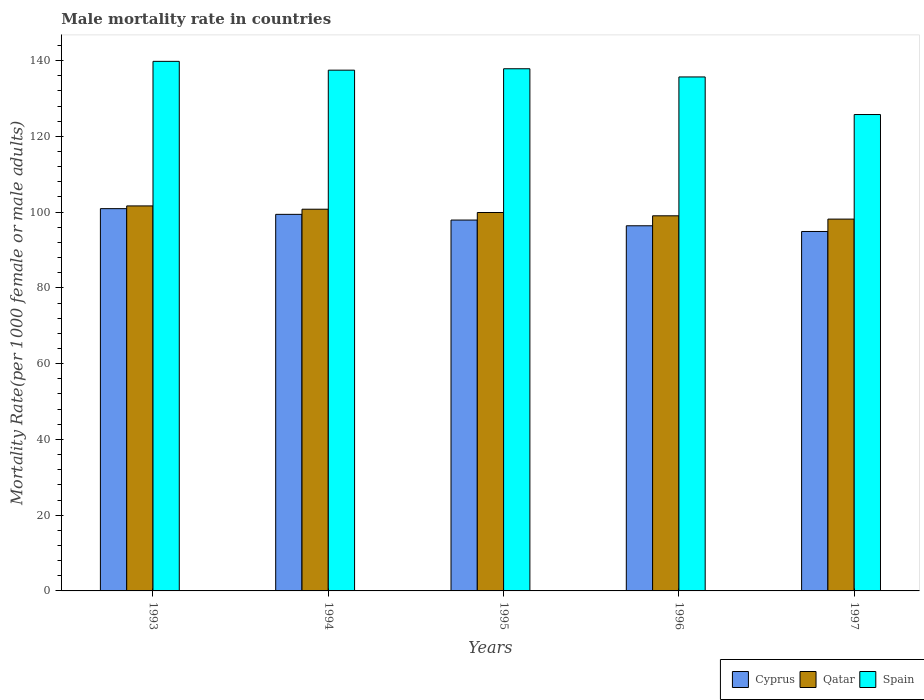How many groups of bars are there?
Provide a short and direct response. 5. Are the number of bars per tick equal to the number of legend labels?
Offer a terse response. Yes. How many bars are there on the 4th tick from the left?
Give a very brief answer. 3. How many bars are there on the 5th tick from the right?
Your answer should be very brief. 3. In how many cases, is the number of bars for a given year not equal to the number of legend labels?
Keep it short and to the point. 0. What is the male mortality rate in Cyprus in 1997?
Keep it short and to the point. 94.89. Across all years, what is the maximum male mortality rate in Spain?
Give a very brief answer. 139.81. Across all years, what is the minimum male mortality rate in Qatar?
Provide a succinct answer. 98.16. In which year was the male mortality rate in Qatar maximum?
Provide a succinct answer. 1993. What is the total male mortality rate in Qatar in the graph?
Provide a succinct answer. 499.51. What is the difference between the male mortality rate in Spain in 1995 and that in 1997?
Provide a succinct answer. 12.09. What is the difference between the male mortality rate in Cyprus in 1993 and the male mortality rate in Spain in 1994?
Offer a terse response. -36.56. What is the average male mortality rate in Cyprus per year?
Keep it short and to the point. 97.91. In the year 1996, what is the difference between the male mortality rate in Qatar and male mortality rate in Spain?
Provide a succinct answer. -36.66. In how many years, is the male mortality rate in Cyprus greater than 140?
Provide a succinct answer. 0. What is the ratio of the male mortality rate in Cyprus in 1993 to that in 1994?
Your response must be concise. 1.02. What is the difference between the highest and the second highest male mortality rate in Cyprus?
Provide a short and direct response. 1.51. What is the difference between the highest and the lowest male mortality rate in Qatar?
Your answer should be compact. 3.48. In how many years, is the male mortality rate in Spain greater than the average male mortality rate in Spain taken over all years?
Your answer should be very brief. 4. What does the 2nd bar from the left in 1996 represents?
Give a very brief answer. Qatar. How many years are there in the graph?
Provide a succinct answer. 5. Does the graph contain any zero values?
Offer a very short reply. No. Does the graph contain grids?
Provide a short and direct response. No. How many legend labels are there?
Your answer should be compact. 3. How are the legend labels stacked?
Ensure brevity in your answer.  Horizontal. What is the title of the graph?
Provide a succinct answer. Male mortality rate in countries. What is the label or title of the Y-axis?
Your answer should be very brief. Mortality Rate(per 1000 female or male adults). What is the Mortality Rate(per 1000 female or male adults) in Cyprus in 1993?
Provide a succinct answer. 100.92. What is the Mortality Rate(per 1000 female or male adults) of Qatar in 1993?
Provide a short and direct response. 101.64. What is the Mortality Rate(per 1000 female or male adults) of Spain in 1993?
Offer a terse response. 139.81. What is the Mortality Rate(per 1000 female or male adults) of Cyprus in 1994?
Your answer should be compact. 99.41. What is the Mortality Rate(per 1000 female or male adults) of Qatar in 1994?
Offer a very short reply. 100.77. What is the Mortality Rate(per 1000 female or male adults) in Spain in 1994?
Make the answer very short. 137.48. What is the Mortality Rate(per 1000 female or male adults) of Cyprus in 1995?
Keep it short and to the point. 97.91. What is the Mortality Rate(per 1000 female or male adults) of Qatar in 1995?
Your answer should be very brief. 99.9. What is the Mortality Rate(per 1000 female or male adults) of Spain in 1995?
Your answer should be compact. 137.85. What is the Mortality Rate(per 1000 female or male adults) in Cyprus in 1996?
Make the answer very short. 96.4. What is the Mortality Rate(per 1000 female or male adults) in Qatar in 1996?
Give a very brief answer. 99.03. What is the Mortality Rate(per 1000 female or male adults) in Spain in 1996?
Your answer should be compact. 135.69. What is the Mortality Rate(per 1000 female or male adults) in Cyprus in 1997?
Provide a short and direct response. 94.89. What is the Mortality Rate(per 1000 female or male adults) in Qatar in 1997?
Keep it short and to the point. 98.16. What is the Mortality Rate(per 1000 female or male adults) of Spain in 1997?
Provide a short and direct response. 125.76. Across all years, what is the maximum Mortality Rate(per 1000 female or male adults) in Cyprus?
Provide a short and direct response. 100.92. Across all years, what is the maximum Mortality Rate(per 1000 female or male adults) in Qatar?
Keep it short and to the point. 101.64. Across all years, what is the maximum Mortality Rate(per 1000 female or male adults) of Spain?
Give a very brief answer. 139.81. Across all years, what is the minimum Mortality Rate(per 1000 female or male adults) in Cyprus?
Offer a terse response. 94.89. Across all years, what is the minimum Mortality Rate(per 1000 female or male adults) in Qatar?
Your answer should be very brief. 98.16. Across all years, what is the minimum Mortality Rate(per 1000 female or male adults) of Spain?
Ensure brevity in your answer.  125.76. What is the total Mortality Rate(per 1000 female or male adults) of Cyprus in the graph?
Offer a very short reply. 489.54. What is the total Mortality Rate(per 1000 female or male adults) of Qatar in the graph?
Your answer should be compact. 499.51. What is the total Mortality Rate(per 1000 female or male adults) in Spain in the graph?
Your answer should be very brief. 676.59. What is the difference between the Mortality Rate(per 1000 female or male adults) of Cyprus in 1993 and that in 1994?
Offer a very short reply. 1.51. What is the difference between the Mortality Rate(per 1000 female or male adults) of Qatar in 1993 and that in 1994?
Make the answer very short. 0.87. What is the difference between the Mortality Rate(per 1000 female or male adults) in Spain in 1993 and that in 1994?
Give a very brief answer. 2.33. What is the difference between the Mortality Rate(per 1000 female or male adults) of Cyprus in 1993 and that in 1995?
Make the answer very short. 3.01. What is the difference between the Mortality Rate(per 1000 female or male adults) of Qatar in 1993 and that in 1995?
Provide a short and direct response. 1.74. What is the difference between the Mortality Rate(per 1000 female or male adults) of Spain in 1993 and that in 1995?
Offer a very short reply. 1.95. What is the difference between the Mortality Rate(per 1000 female or male adults) of Cyprus in 1993 and that in 1996?
Give a very brief answer. 4.52. What is the difference between the Mortality Rate(per 1000 female or male adults) in Qatar in 1993 and that in 1996?
Provide a short and direct response. 2.61. What is the difference between the Mortality Rate(per 1000 female or male adults) of Spain in 1993 and that in 1996?
Your answer should be compact. 4.12. What is the difference between the Mortality Rate(per 1000 female or male adults) in Cyprus in 1993 and that in 1997?
Provide a short and direct response. 6.03. What is the difference between the Mortality Rate(per 1000 female or male adults) of Qatar in 1993 and that in 1997?
Your answer should be compact. 3.48. What is the difference between the Mortality Rate(per 1000 female or male adults) in Spain in 1993 and that in 1997?
Offer a very short reply. 14.04. What is the difference between the Mortality Rate(per 1000 female or male adults) in Cyprus in 1994 and that in 1995?
Offer a very short reply. 1.51. What is the difference between the Mortality Rate(per 1000 female or male adults) of Qatar in 1994 and that in 1995?
Your answer should be compact. 0.87. What is the difference between the Mortality Rate(per 1000 female or male adults) in Spain in 1994 and that in 1995?
Offer a terse response. -0.38. What is the difference between the Mortality Rate(per 1000 female or male adults) of Cyprus in 1994 and that in 1996?
Provide a succinct answer. 3.01. What is the difference between the Mortality Rate(per 1000 female or male adults) in Qatar in 1994 and that in 1996?
Your response must be concise. 1.74. What is the difference between the Mortality Rate(per 1000 female or male adults) of Spain in 1994 and that in 1996?
Ensure brevity in your answer.  1.79. What is the difference between the Mortality Rate(per 1000 female or male adults) in Cyprus in 1994 and that in 1997?
Offer a terse response. 4.52. What is the difference between the Mortality Rate(per 1000 female or male adults) in Qatar in 1994 and that in 1997?
Provide a short and direct response. 2.61. What is the difference between the Mortality Rate(per 1000 female or male adults) in Spain in 1994 and that in 1997?
Offer a very short reply. 11.71. What is the difference between the Mortality Rate(per 1000 female or male adults) of Cyprus in 1995 and that in 1996?
Give a very brief answer. 1.51. What is the difference between the Mortality Rate(per 1000 female or male adults) of Qatar in 1995 and that in 1996?
Your answer should be very brief. 0.87. What is the difference between the Mortality Rate(per 1000 female or male adults) in Spain in 1995 and that in 1996?
Provide a short and direct response. 2.16. What is the difference between the Mortality Rate(per 1000 female or male adults) of Cyprus in 1995 and that in 1997?
Ensure brevity in your answer.  3.01. What is the difference between the Mortality Rate(per 1000 female or male adults) of Qatar in 1995 and that in 1997?
Offer a terse response. 1.74. What is the difference between the Mortality Rate(per 1000 female or male adults) of Spain in 1995 and that in 1997?
Provide a succinct answer. 12.09. What is the difference between the Mortality Rate(per 1000 female or male adults) in Cyprus in 1996 and that in 1997?
Ensure brevity in your answer.  1.51. What is the difference between the Mortality Rate(per 1000 female or male adults) in Qatar in 1996 and that in 1997?
Your answer should be very brief. 0.87. What is the difference between the Mortality Rate(per 1000 female or male adults) of Spain in 1996 and that in 1997?
Provide a short and direct response. 9.93. What is the difference between the Mortality Rate(per 1000 female or male adults) of Cyprus in 1993 and the Mortality Rate(per 1000 female or male adults) of Qatar in 1994?
Your response must be concise. 0.15. What is the difference between the Mortality Rate(per 1000 female or male adults) in Cyprus in 1993 and the Mortality Rate(per 1000 female or male adults) in Spain in 1994?
Ensure brevity in your answer.  -36.56. What is the difference between the Mortality Rate(per 1000 female or male adults) in Qatar in 1993 and the Mortality Rate(per 1000 female or male adults) in Spain in 1994?
Offer a terse response. -35.83. What is the difference between the Mortality Rate(per 1000 female or male adults) of Cyprus in 1993 and the Mortality Rate(per 1000 female or male adults) of Spain in 1995?
Your response must be concise. -36.93. What is the difference between the Mortality Rate(per 1000 female or male adults) in Qatar in 1993 and the Mortality Rate(per 1000 female or male adults) in Spain in 1995?
Give a very brief answer. -36.21. What is the difference between the Mortality Rate(per 1000 female or male adults) of Cyprus in 1993 and the Mortality Rate(per 1000 female or male adults) of Qatar in 1996?
Give a very brief answer. 1.89. What is the difference between the Mortality Rate(per 1000 female or male adults) in Cyprus in 1993 and the Mortality Rate(per 1000 female or male adults) in Spain in 1996?
Give a very brief answer. -34.77. What is the difference between the Mortality Rate(per 1000 female or male adults) of Qatar in 1993 and the Mortality Rate(per 1000 female or male adults) of Spain in 1996?
Offer a very short reply. -34.05. What is the difference between the Mortality Rate(per 1000 female or male adults) of Cyprus in 1993 and the Mortality Rate(per 1000 female or male adults) of Qatar in 1997?
Give a very brief answer. 2.76. What is the difference between the Mortality Rate(per 1000 female or male adults) in Cyprus in 1993 and the Mortality Rate(per 1000 female or male adults) in Spain in 1997?
Your answer should be very brief. -24.84. What is the difference between the Mortality Rate(per 1000 female or male adults) of Qatar in 1993 and the Mortality Rate(per 1000 female or male adults) of Spain in 1997?
Ensure brevity in your answer.  -24.12. What is the difference between the Mortality Rate(per 1000 female or male adults) of Cyprus in 1994 and the Mortality Rate(per 1000 female or male adults) of Qatar in 1995?
Make the answer very short. -0.49. What is the difference between the Mortality Rate(per 1000 female or male adults) in Cyprus in 1994 and the Mortality Rate(per 1000 female or male adults) in Spain in 1995?
Provide a short and direct response. -38.44. What is the difference between the Mortality Rate(per 1000 female or male adults) in Qatar in 1994 and the Mortality Rate(per 1000 female or male adults) in Spain in 1995?
Provide a succinct answer. -37.08. What is the difference between the Mortality Rate(per 1000 female or male adults) of Cyprus in 1994 and the Mortality Rate(per 1000 female or male adults) of Qatar in 1996?
Your response must be concise. 0.38. What is the difference between the Mortality Rate(per 1000 female or male adults) in Cyprus in 1994 and the Mortality Rate(per 1000 female or male adults) in Spain in 1996?
Offer a very short reply. -36.28. What is the difference between the Mortality Rate(per 1000 female or male adults) of Qatar in 1994 and the Mortality Rate(per 1000 female or male adults) of Spain in 1996?
Give a very brief answer. -34.92. What is the difference between the Mortality Rate(per 1000 female or male adults) in Cyprus in 1994 and the Mortality Rate(per 1000 female or male adults) in Qatar in 1997?
Offer a very short reply. 1.25. What is the difference between the Mortality Rate(per 1000 female or male adults) in Cyprus in 1994 and the Mortality Rate(per 1000 female or male adults) in Spain in 1997?
Make the answer very short. -26.35. What is the difference between the Mortality Rate(per 1000 female or male adults) in Qatar in 1994 and the Mortality Rate(per 1000 female or male adults) in Spain in 1997?
Offer a terse response. -24.99. What is the difference between the Mortality Rate(per 1000 female or male adults) in Cyprus in 1995 and the Mortality Rate(per 1000 female or male adults) in Qatar in 1996?
Offer a very short reply. -1.12. What is the difference between the Mortality Rate(per 1000 female or male adults) of Cyprus in 1995 and the Mortality Rate(per 1000 female or male adults) of Spain in 1996?
Ensure brevity in your answer.  -37.78. What is the difference between the Mortality Rate(per 1000 female or male adults) of Qatar in 1995 and the Mortality Rate(per 1000 female or male adults) of Spain in 1996?
Offer a terse response. -35.79. What is the difference between the Mortality Rate(per 1000 female or male adults) in Cyprus in 1995 and the Mortality Rate(per 1000 female or male adults) in Qatar in 1997?
Offer a very short reply. -0.25. What is the difference between the Mortality Rate(per 1000 female or male adults) in Cyprus in 1995 and the Mortality Rate(per 1000 female or male adults) in Spain in 1997?
Make the answer very short. -27.86. What is the difference between the Mortality Rate(per 1000 female or male adults) of Qatar in 1995 and the Mortality Rate(per 1000 female or male adults) of Spain in 1997?
Your answer should be compact. -25.86. What is the difference between the Mortality Rate(per 1000 female or male adults) of Cyprus in 1996 and the Mortality Rate(per 1000 female or male adults) of Qatar in 1997?
Your answer should be compact. -1.76. What is the difference between the Mortality Rate(per 1000 female or male adults) in Cyprus in 1996 and the Mortality Rate(per 1000 female or male adults) in Spain in 1997?
Keep it short and to the point. -29.36. What is the difference between the Mortality Rate(per 1000 female or male adults) in Qatar in 1996 and the Mortality Rate(per 1000 female or male adults) in Spain in 1997?
Your answer should be compact. -26.73. What is the average Mortality Rate(per 1000 female or male adults) in Cyprus per year?
Provide a short and direct response. 97.91. What is the average Mortality Rate(per 1000 female or male adults) in Qatar per year?
Ensure brevity in your answer.  99.9. What is the average Mortality Rate(per 1000 female or male adults) in Spain per year?
Make the answer very short. 135.32. In the year 1993, what is the difference between the Mortality Rate(per 1000 female or male adults) of Cyprus and Mortality Rate(per 1000 female or male adults) of Qatar?
Provide a short and direct response. -0.72. In the year 1993, what is the difference between the Mortality Rate(per 1000 female or male adults) of Cyprus and Mortality Rate(per 1000 female or male adults) of Spain?
Provide a succinct answer. -38.89. In the year 1993, what is the difference between the Mortality Rate(per 1000 female or male adults) in Qatar and Mortality Rate(per 1000 female or male adults) in Spain?
Make the answer very short. -38.16. In the year 1994, what is the difference between the Mortality Rate(per 1000 female or male adults) in Cyprus and Mortality Rate(per 1000 female or male adults) in Qatar?
Keep it short and to the point. -1.36. In the year 1994, what is the difference between the Mortality Rate(per 1000 female or male adults) in Cyprus and Mortality Rate(per 1000 female or male adults) in Spain?
Your answer should be compact. -38.06. In the year 1994, what is the difference between the Mortality Rate(per 1000 female or male adults) in Qatar and Mortality Rate(per 1000 female or male adults) in Spain?
Provide a short and direct response. -36.7. In the year 1995, what is the difference between the Mortality Rate(per 1000 female or male adults) of Cyprus and Mortality Rate(per 1000 female or male adults) of Qatar?
Provide a short and direct response. -2. In the year 1995, what is the difference between the Mortality Rate(per 1000 female or male adults) in Cyprus and Mortality Rate(per 1000 female or male adults) in Spain?
Ensure brevity in your answer.  -39.95. In the year 1995, what is the difference between the Mortality Rate(per 1000 female or male adults) in Qatar and Mortality Rate(per 1000 female or male adults) in Spain?
Your response must be concise. -37.95. In the year 1996, what is the difference between the Mortality Rate(per 1000 female or male adults) in Cyprus and Mortality Rate(per 1000 female or male adults) in Qatar?
Provide a succinct answer. -2.63. In the year 1996, what is the difference between the Mortality Rate(per 1000 female or male adults) in Cyprus and Mortality Rate(per 1000 female or male adults) in Spain?
Keep it short and to the point. -39.29. In the year 1996, what is the difference between the Mortality Rate(per 1000 female or male adults) of Qatar and Mortality Rate(per 1000 female or male adults) of Spain?
Make the answer very short. -36.66. In the year 1997, what is the difference between the Mortality Rate(per 1000 female or male adults) of Cyprus and Mortality Rate(per 1000 female or male adults) of Qatar?
Ensure brevity in your answer.  -3.27. In the year 1997, what is the difference between the Mortality Rate(per 1000 female or male adults) in Cyprus and Mortality Rate(per 1000 female or male adults) in Spain?
Your answer should be very brief. -30.87. In the year 1997, what is the difference between the Mortality Rate(per 1000 female or male adults) of Qatar and Mortality Rate(per 1000 female or male adults) of Spain?
Provide a succinct answer. -27.6. What is the ratio of the Mortality Rate(per 1000 female or male adults) of Cyprus in 1993 to that in 1994?
Offer a very short reply. 1.02. What is the ratio of the Mortality Rate(per 1000 female or male adults) of Qatar in 1993 to that in 1994?
Your response must be concise. 1.01. What is the ratio of the Mortality Rate(per 1000 female or male adults) of Spain in 1993 to that in 1994?
Offer a very short reply. 1.02. What is the ratio of the Mortality Rate(per 1000 female or male adults) in Cyprus in 1993 to that in 1995?
Provide a succinct answer. 1.03. What is the ratio of the Mortality Rate(per 1000 female or male adults) in Qatar in 1993 to that in 1995?
Your answer should be very brief. 1.02. What is the ratio of the Mortality Rate(per 1000 female or male adults) of Spain in 1993 to that in 1995?
Your answer should be very brief. 1.01. What is the ratio of the Mortality Rate(per 1000 female or male adults) of Cyprus in 1993 to that in 1996?
Your response must be concise. 1.05. What is the ratio of the Mortality Rate(per 1000 female or male adults) in Qatar in 1993 to that in 1996?
Your answer should be compact. 1.03. What is the ratio of the Mortality Rate(per 1000 female or male adults) of Spain in 1993 to that in 1996?
Provide a succinct answer. 1.03. What is the ratio of the Mortality Rate(per 1000 female or male adults) in Cyprus in 1993 to that in 1997?
Offer a terse response. 1.06. What is the ratio of the Mortality Rate(per 1000 female or male adults) of Qatar in 1993 to that in 1997?
Keep it short and to the point. 1.04. What is the ratio of the Mortality Rate(per 1000 female or male adults) of Spain in 1993 to that in 1997?
Ensure brevity in your answer.  1.11. What is the ratio of the Mortality Rate(per 1000 female or male adults) of Cyprus in 1994 to that in 1995?
Make the answer very short. 1.02. What is the ratio of the Mortality Rate(per 1000 female or male adults) in Qatar in 1994 to that in 1995?
Offer a very short reply. 1.01. What is the ratio of the Mortality Rate(per 1000 female or male adults) in Spain in 1994 to that in 1995?
Your answer should be compact. 1. What is the ratio of the Mortality Rate(per 1000 female or male adults) of Cyprus in 1994 to that in 1996?
Offer a very short reply. 1.03. What is the ratio of the Mortality Rate(per 1000 female or male adults) of Qatar in 1994 to that in 1996?
Your answer should be very brief. 1.02. What is the ratio of the Mortality Rate(per 1000 female or male adults) of Spain in 1994 to that in 1996?
Provide a short and direct response. 1.01. What is the ratio of the Mortality Rate(per 1000 female or male adults) in Cyprus in 1994 to that in 1997?
Ensure brevity in your answer.  1.05. What is the ratio of the Mortality Rate(per 1000 female or male adults) of Qatar in 1994 to that in 1997?
Make the answer very short. 1.03. What is the ratio of the Mortality Rate(per 1000 female or male adults) of Spain in 1994 to that in 1997?
Keep it short and to the point. 1.09. What is the ratio of the Mortality Rate(per 1000 female or male adults) of Cyprus in 1995 to that in 1996?
Your answer should be compact. 1.02. What is the ratio of the Mortality Rate(per 1000 female or male adults) of Qatar in 1995 to that in 1996?
Offer a very short reply. 1.01. What is the ratio of the Mortality Rate(per 1000 female or male adults) in Spain in 1995 to that in 1996?
Ensure brevity in your answer.  1.02. What is the ratio of the Mortality Rate(per 1000 female or male adults) of Cyprus in 1995 to that in 1997?
Make the answer very short. 1.03. What is the ratio of the Mortality Rate(per 1000 female or male adults) of Qatar in 1995 to that in 1997?
Give a very brief answer. 1.02. What is the ratio of the Mortality Rate(per 1000 female or male adults) in Spain in 1995 to that in 1997?
Keep it short and to the point. 1.1. What is the ratio of the Mortality Rate(per 1000 female or male adults) in Cyprus in 1996 to that in 1997?
Your answer should be compact. 1.02. What is the ratio of the Mortality Rate(per 1000 female or male adults) in Qatar in 1996 to that in 1997?
Offer a terse response. 1.01. What is the ratio of the Mortality Rate(per 1000 female or male adults) in Spain in 1996 to that in 1997?
Ensure brevity in your answer.  1.08. What is the difference between the highest and the second highest Mortality Rate(per 1000 female or male adults) of Cyprus?
Keep it short and to the point. 1.51. What is the difference between the highest and the second highest Mortality Rate(per 1000 female or male adults) in Qatar?
Offer a terse response. 0.87. What is the difference between the highest and the second highest Mortality Rate(per 1000 female or male adults) of Spain?
Make the answer very short. 1.95. What is the difference between the highest and the lowest Mortality Rate(per 1000 female or male adults) in Cyprus?
Make the answer very short. 6.03. What is the difference between the highest and the lowest Mortality Rate(per 1000 female or male adults) of Qatar?
Give a very brief answer. 3.48. What is the difference between the highest and the lowest Mortality Rate(per 1000 female or male adults) of Spain?
Keep it short and to the point. 14.04. 